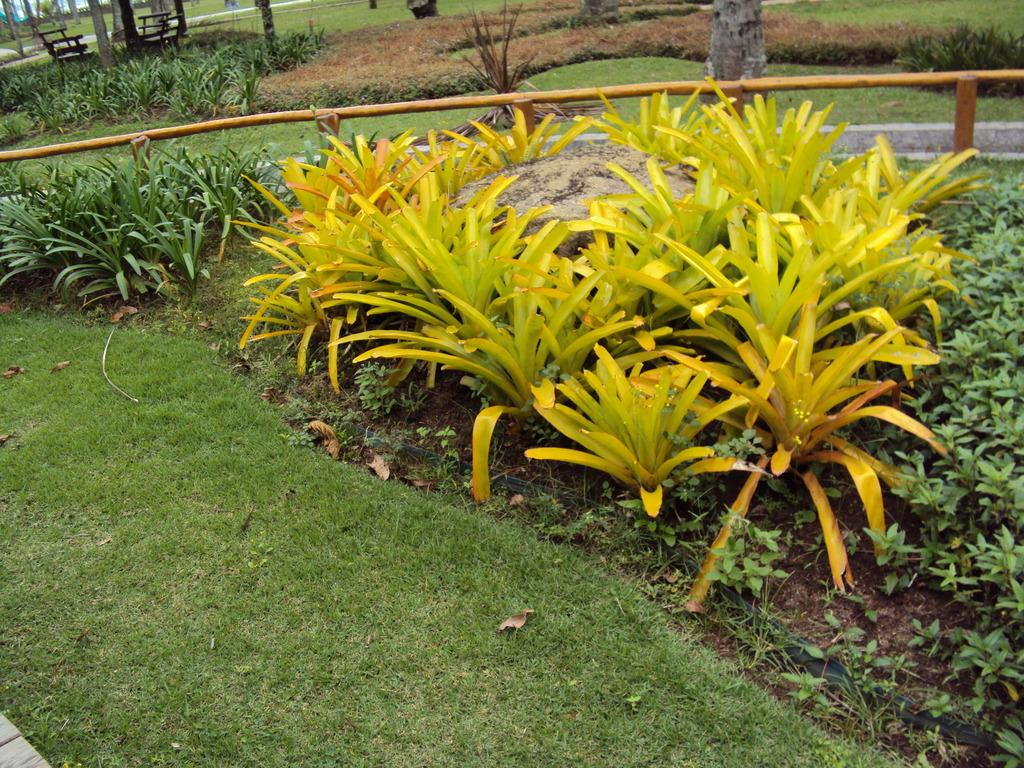What type of vegetation is visible in the foreground of the image? There is grass in the foreground of the image. What can be seen in the middle of the image? There are plants and a rock in the middle of the image. What is present on the top of the image? There is grass, plants, and benches on the top of the image. What type of business is being conducted on the grass in the image? There is no indication of any business being conducted in the image; it primarily features vegetation and a rock. Are there any police officers visible in the image? There are no police officers present in the image. 